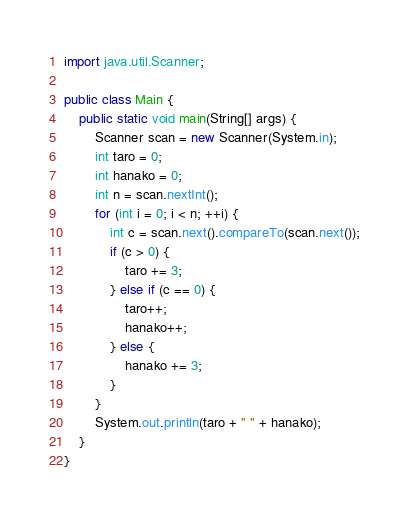<code> <loc_0><loc_0><loc_500><loc_500><_Java_>import java.util.Scanner;
 
public class Main {
    public static void main(String[] args) {
        Scanner scan = new Scanner(System.in);
        int taro = 0;
        int hanako = 0;
        int n = scan.nextInt();
        for (int i = 0; i < n; ++i) {
            int c = scan.next().compareTo(scan.next());
            if (c > 0) {
                taro += 3;
            } else if (c == 0) {
                taro++;
                hanako++;
            } else {
                hanako += 3;
            }
        }
        System.out.println(taro + " " + hanako);
    }
}</code> 